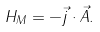<formula> <loc_0><loc_0><loc_500><loc_500>H _ { M } = - \vec { j } \cdot \vec { A } .</formula> 